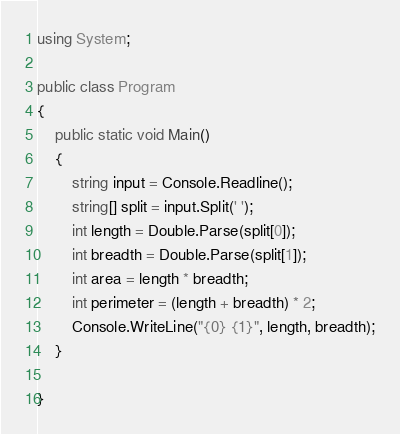<code> <loc_0><loc_0><loc_500><loc_500><_C#_>using System;

public class Program
{
    public static void Main()
    {
        string input = Console.Readline();
        string[] split = input.Split(' ');
        int length = Double.Parse(split[0]);
        int breadth = Double.Parse(split[1]);
        int area = length * breadth;
        int perimeter = (length + breadth) * 2;
        Console.WriteLine("{0} {1}", length, breadth);
    }
    
}
</code> 